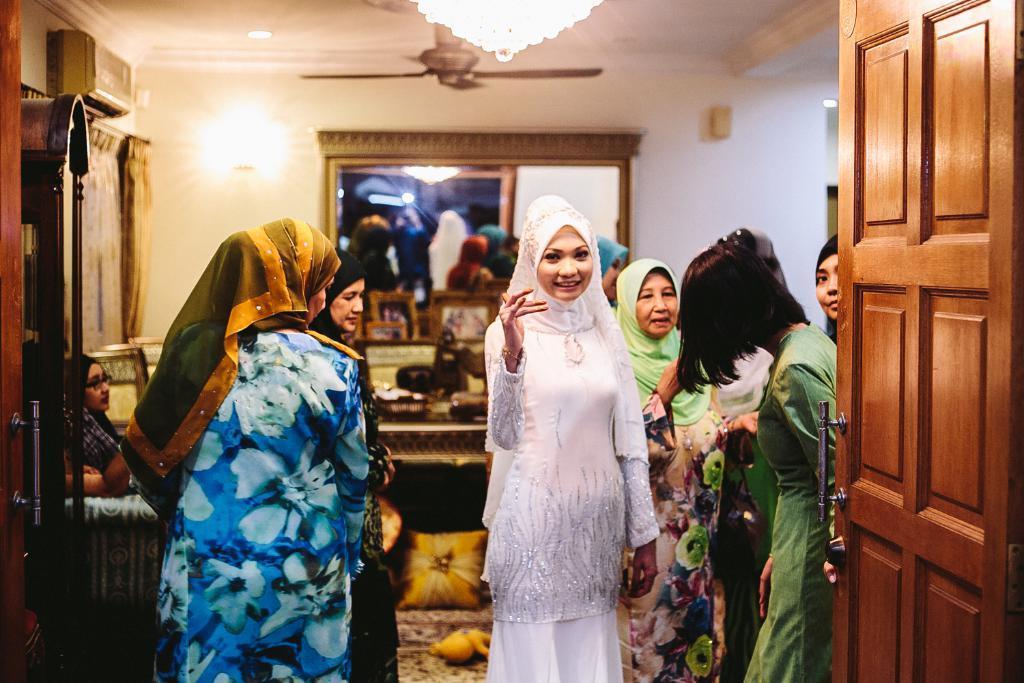In one or two sentences, can you explain what this image depicts? This image is taken indoors. In the background there is a wall. There is a mirror on the wall. At the top of the image there is a ceiling with a few lights, a fan and a chandelier. On the left side of the image there is an air conditioner on the wall and there is a curtain. There is a door and a woman is sitting on the couch. On the right side of the image there is a door. In the middle of the image a few women are standing on the floor and there is a table with a few things on it. 